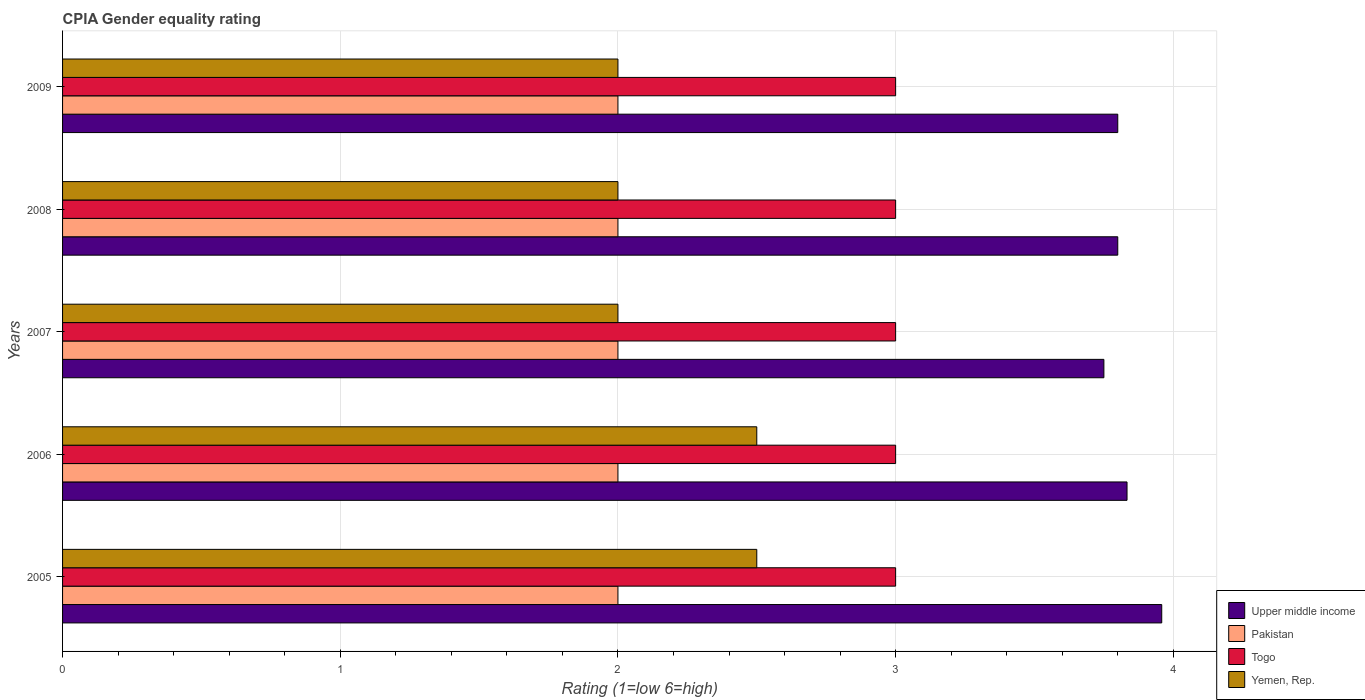Are the number of bars on each tick of the Y-axis equal?
Provide a succinct answer. Yes. How many bars are there on the 1st tick from the bottom?
Keep it short and to the point. 4. What is the CPIA rating in Togo in 2008?
Make the answer very short. 3. Across all years, what is the maximum CPIA rating in Togo?
Offer a terse response. 3. Across all years, what is the minimum CPIA rating in Upper middle income?
Offer a terse response. 3.75. In which year was the CPIA rating in Upper middle income maximum?
Offer a very short reply. 2005. What is the total CPIA rating in Togo in the graph?
Offer a terse response. 15. What is the difference between the CPIA rating in Yemen, Rep. in 2009 and the CPIA rating in Upper middle income in 2008?
Ensure brevity in your answer.  -1.8. Is the difference between the CPIA rating in Togo in 2005 and 2009 greater than the difference between the CPIA rating in Yemen, Rep. in 2005 and 2009?
Provide a short and direct response. No. What is the difference between the highest and the lowest CPIA rating in Upper middle income?
Your response must be concise. 0.21. Is the sum of the CPIA rating in Togo in 2008 and 2009 greater than the maximum CPIA rating in Upper middle income across all years?
Offer a terse response. Yes. What does the 3rd bar from the top in 2009 represents?
Ensure brevity in your answer.  Pakistan. What does the 3rd bar from the bottom in 2009 represents?
Provide a succinct answer. Togo. Is it the case that in every year, the sum of the CPIA rating in Upper middle income and CPIA rating in Yemen, Rep. is greater than the CPIA rating in Togo?
Keep it short and to the point. Yes. How many bars are there?
Offer a terse response. 20. Are all the bars in the graph horizontal?
Offer a terse response. Yes. How many years are there in the graph?
Your answer should be very brief. 5. What is the difference between two consecutive major ticks on the X-axis?
Provide a succinct answer. 1. Does the graph contain any zero values?
Your answer should be compact. No. Where does the legend appear in the graph?
Your answer should be compact. Bottom right. How many legend labels are there?
Give a very brief answer. 4. How are the legend labels stacked?
Give a very brief answer. Vertical. What is the title of the graph?
Ensure brevity in your answer.  CPIA Gender equality rating. Does "Monaco" appear as one of the legend labels in the graph?
Provide a succinct answer. No. What is the label or title of the Y-axis?
Keep it short and to the point. Years. What is the Rating (1=low 6=high) of Upper middle income in 2005?
Offer a terse response. 3.96. What is the Rating (1=low 6=high) of Togo in 2005?
Provide a succinct answer. 3. What is the Rating (1=low 6=high) in Yemen, Rep. in 2005?
Offer a terse response. 2.5. What is the Rating (1=low 6=high) in Upper middle income in 2006?
Offer a very short reply. 3.83. What is the Rating (1=low 6=high) in Yemen, Rep. in 2006?
Give a very brief answer. 2.5. What is the Rating (1=low 6=high) in Upper middle income in 2007?
Make the answer very short. 3.75. What is the Rating (1=low 6=high) of Pakistan in 2007?
Your answer should be very brief. 2. What is the Rating (1=low 6=high) of Togo in 2007?
Make the answer very short. 3. What is the Rating (1=low 6=high) of Upper middle income in 2008?
Offer a very short reply. 3.8. What is the Rating (1=low 6=high) of Pakistan in 2008?
Provide a short and direct response. 2. What is the Rating (1=low 6=high) in Yemen, Rep. in 2008?
Give a very brief answer. 2. What is the Rating (1=low 6=high) of Upper middle income in 2009?
Your answer should be compact. 3.8. What is the Rating (1=low 6=high) in Togo in 2009?
Offer a terse response. 3. What is the Rating (1=low 6=high) of Yemen, Rep. in 2009?
Ensure brevity in your answer.  2. Across all years, what is the maximum Rating (1=low 6=high) of Upper middle income?
Your answer should be very brief. 3.96. Across all years, what is the maximum Rating (1=low 6=high) in Pakistan?
Your answer should be very brief. 2. Across all years, what is the maximum Rating (1=low 6=high) of Togo?
Offer a terse response. 3. Across all years, what is the minimum Rating (1=low 6=high) in Upper middle income?
Your answer should be very brief. 3.75. Across all years, what is the minimum Rating (1=low 6=high) of Yemen, Rep.?
Your response must be concise. 2. What is the total Rating (1=low 6=high) of Upper middle income in the graph?
Your answer should be compact. 19.14. What is the total Rating (1=low 6=high) in Pakistan in the graph?
Offer a very short reply. 10. What is the total Rating (1=low 6=high) of Togo in the graph?
Make the answer very short. 15. What is the difference between the Rating (1=low 6=high) of Upper middle income in 2005 and that in 2006?
Keep it short and to the point. 0.12. What is the difference between the Rating (1=low 6=high) in Pakistan in 2005 and that in 2006?
Your answer should be very brief. 0. What is the difference between the Rating (1=low 6=high) in Togo in 2005 and that in 2006?
Ensure brevity in your answer.  0. What is the difference between the Rating (1=low 6=high) of Yemen, Rep. in 2005 and that in 2006?
Give a very brief answer. 0. What is the difference between the Rating (1=low 6=high) of Upper middle income in 2005 and that in 2007?
Ensure brevity in your answer.  0.21. What is the difference between the Rating (1=low 6=high) in Pakistan in 2005 and that in 2007?
Ensure brevity in your answer.  0. What is the difference between the Rating (1=low 6=high) in Yemen, Rep. in 2005 and that in 2007?
Your answer should be very brief. 0.5. What is the difference between the Rating (1=low 6=high) of Upper middle income in 2005 and that in 2008?
Your answer should be compact. 0.16. What is the difference between the Rating (1=low 6=high) of Yemen, Rep. in 2005 and that in 2008?
Ensure brevity in your answer.  0.5. What is the difference between the Rating (1=low 6=high) of Upper middle income in 2005 and that in 2009?
Make the answer very short. 0.16. What is the difference between the Rating (1=low 6=high) of Pakistan in 2005 and that in 2009?
Ensure brevity in your answer.  0. What is the difference between the Rating (1=low 6=high) of Togo in 2005 and that in 2009?
Provide a short and direct response. 0. What is the difference between the Rating (1=low 6=high) of Yemen, Rep. in 2005 and that in 2009?
Provide a short and direct response. 0.5. What is the difference between the Rating (1=low 6=high) in Upper middle income in 2006 and that in 2007?
Make the answer very short. 0.08. What is the difference between the Rating (1=low 6=high) in Pakistan in 2006 and that in 2007?
Ensure brevity in your answer.  0. What is the difference between the Rating (1=low 6=high) in Togo in 2006 and that in 2007?
Your answer should be compact. 0. What is the difference between the Rating (1=low 6=high) in Pakistan in 2006 and that in 2008?
Ensure brevity in your answer.  0. What is the difference between the Rating (1=low 6=high) of Togo in 2006 and that in 2008?
Ensure brevity in your answer.  0. What is the difference between the Rating (1=low 6=high) in Yemen, Rep. in 2006 and that in 2008?
Offer a very short reply. 0.5. What is the difference between the Rating (1=low 6=high) in Upper middle income in 2006 and that in 2009?
Your response must be concise. 0.03. What is the difference between the Rating (1=low 6=high) in Pakistan in 2006 and that in 2009?
Your response must be concise. 0. What is the difference between the Rating (1=low 6=high) in Togo in 2006 and that in 2009?
Make the answer very short. 0. What is the difference between the Rating (1=low 6=high) of Yemen, Rep. in 2007 and that in 2008?
Your answer should be compact. 0. What is the difference between the Rating (1=low 6=high) of Pakistan in 2007 and that in 2009?
Ensure brevity in your answer.  0. What is the difference between the Rating (1=low 6=high) in Upper middle income in 2008 and that in 2009?
Give a very brief answer. 0. What is the difference between the Rating (1=low 6=high) in Togo in 2008 and that in 2009?
Your response must be concise. 0. What is the difference between the Rating (1=low 6=high) of Yemen, Rep. in 2008 and that in 2009?
Make the answer very short. 0. What is the difference between the Rating (1=low 6=high) of Upper middle income in 2005 and the Rating (1=low 6=high) of Pakistan in 2006?
Provide a succinct answer. 1.96. What is the difference between the Rating (1=low 6=high) in Upper middle income in 2005 and the Rating (1=low 6=high) in Yemen, Rep. in 2006?
Your response must be concise. 1.46. What is the difference between the Rating (1=low 6=high) in Pakistan in 2005 and the Rating (1=low 6=high) in Togo in 2006?
Your answer should be compact. -1. What is the difference between the Rating (1=low 6=high) in Pakistan in 2005 and the Rating (1=low 6=high) in Yemen, Rep. in 2006?
Give a very brief answer. -0.5. What is the difference between the Rating (1=low 6=high) of Togo in 2005 and the Rating (1=low 6=high) of Yemen, Rep. in 2006?
Offer a very short reply. 0.5. What is the difference between the Rating (1=low 6=high) in Upper middle income in 2005 and the Rating (1=low 6=high) in Pakistan in 2007?
Your answer should be compact. 1.96. What is the difference between the Rating (1=low 6=high) of Upper middle income in 2005 and the Rating (1=low 6=high) of Togo in 2007?
Make the answer very short. 0.96. What is the difference between the Rating (1=low 6=high) in Upper middle income in 2005 and the Rating (1=low 6=high) in Yemen, Rep. in 2007?
Make the answer very short. 1.96. What is the difference between the Rating (1=low 6=high) of Pakistan in 2005 and the Rating (1=low 6=high) of Yemen, Rep. in 2007?
Make the answer very short. 0. What is the difference between the Rating (1=low 6=high) in Upper middle income in 2005 and the Rating (1=low 6=high) in Pakistan in 2008?
Provide a short and direct response. 1.96. What is the difference between the Rating (1=low 6=high) in Upper middle income in 2005 and the Rating (1=low 6=high) in Yemen, Rep. in 2008?
Ensure brevity in your answer.  1.96. What is the difference between the Rating (1=low 6=high) in Pakistan in 2005 and the Rating (1=low 6=high) in Yemen, Rep. in 2008?
Offer a terse response. 0. What is the difference between the Rating (1=low 6=high) in Upper middle income in 2005 and the Rating (1=low 6=high) in Pakistan in 2009?
Give a very brief answer. 1.96. What is the difference between the Rating (1=low 6=high) of Upper middle income in 2005 and the Rating (1=low 6=high) of Yemen, Rep. in 2009?
Offer a very short reply. 1.96. What is the difference between the Rating (1=low 6=high) in Pakistan in 2005 and the Rating (1=low 6=high) in Togo in 2009?
Give a very brief answer. -1. What is the difference between the Rating (1=low 6=high) in Togo in 2005 and the Rating (1=low 6=high) in Yemen, Rep. in 2009?
Give a very brief answer. 1. What is the difference between the Rating (1=low 6=high) of Upper middle income in 2006 and the Rating (1=low 6=high) of Pakistan in 2007?
Your response must be concise. 1.83. What is the difference between the Rating (1=low 6=high) of Upper middle income in 2006 and the Rating (1=low 6=high) of Yemen, Rep. in 2007?
Ensure brevity in your answer.  1.83. What is the difference between the Rating (1=low 6=high) in Upper middle income in 2006 and the Rating (1=low 6=high) in Pakistan in 2008?
Ensure brevity in your answer.  1.83. What is the difference between the Rating (1=low 6=high) in Upper middle income in 2006 and the Rating (1=low 6=high) in Yemen, Rep. in 2008?
Make the answer very short. 1.83. What is the difference between the Rating (1=low 6=high) in Pakistan in 2006 and the Rating (1=low 6=high) in Togo in 2008?
Offer a very short reply. -1. What is the difference between the Rating (1=low 6=high) in Upper middle income in 2006 and the Rating (1=low 6=high) in Pakistan in 2009?
Give a very brief answer. 1.83. What is the difference between the Rating (1=low 6=high) in Upper middle income in 2006 and the Rating (1=low 6=high) in Togo in 2009?
Keep it short and to the point. 0.83. What is the difference between the Rating (1=low 6=high) of Upper middle income in 2006 and the Rating (1=low 6=high) of Yemen, Rep. in 2009?
Offer a terse response. 1.83. What is the difference between the Rating (1=low 6=high) in Pakistan in 2006 and the Rating (1=low 6=high) in Yemen, Rep. in 2009?
Make the answer very short. 0. What is the difference between the Rating (1=low 6=high) in Togo in 2006 and the Rating (1=low 6=high) in Yemen, Rep. in 2009?
Give a very brief answer. 1. What is the difference between the Rating (1=low 6=high) of Upper middle income in 2007 and the Rating (1=low 6=high) of Togo in 2008?
Offer a very short reply. 0.75. What is the difference between the Rating (1=low 6=high) of Pakistan in 2007 and the Rating (1=low 6=high) of Togo in 2008?
Provide a succinct answer. -1. What is the difference between the Rating (1=low 6=high) of Pakistan in 2007 and the Rating (1=low 6=high) of Yemen, Rep. in 2008?
Offer a terse response. 0. What is the difference between the Rating (1=low 6=high) of Togo in 2007 and the Rating (1=low 6=high) of Yemen, Rep. in 2008?
Offer a terse response. 1. What is the difference between the Rating (1=low 6=high) of Upper middle income in 2007 and the Rating (1=low 6=high) of Togo in 2009?
Offer a terse response. 0.75. What is the difference between the Rating (1=low 6=high) in Upper middle income in 2007 and the Rating (1=low 6=high) in Yemen, Rep. in 2009?
Your answer should be very brief. 1.75. What is the difference between the Rating (1=low 6=high) of Pakistan in 2007 and the Rating (1=low 6=high) of Togo in 2009?
Ensure brevity in your answer.  -1. What is the difference between the Rating (1=low 6=high) of Upper middle income in 2008 and the Rating (1=low 6=high) of Pakistan in 2009?
Give a very brief answer. 1.8. What is the difference between the Rating (1=low 6=high) in Upper middle income in 2008 and the Rating (1=low 6=high) in Togo in 2009?
Offer a very short reply. 0.8. What is the difference between the Rating (1=low 6=high) of Pakistan in 2008 and the Rating (1=low 6=high) of Togo in 2009?
Give a very brief answer. -1. What is the average Rating (1=low 6=high) in Upper middle income per year?
Make the answer very short. 3.83. What is the average Rating (1=low 6=high) in Pakistan per year?
Keep it short and to the point. 2. What is the average Rating (1=low 6=high) in Yemen, Rep. per year?
Your answer should be very brief. 2.2. In the year 2005, what is the difference between the Rating (1=low 6=high) of Upper middle income and Rating (1=low 6=high) of Pakistan?
Offer a very short reply. 1.96. In the year 2005, what is the difference between the Rating (1=low 6=high) of Upper middle income and Rating (1=low 6=high) of Togo?
Make the answer very short. 0.96. In the year 2005, what is the difference between the Rating (1=low 6=high) in Upper middle income and Rating (1=low 6=high) in Yemen, Rep.?
Give a very brief answer. 1.46. In the year 2005, what is the difference between the Rating (1=low 6=high) in Pakistan and Rating (1=low 6=high) in Togo?
Your response must be concise. -1. In the year 2005, what is the difference between the Rating (1=low 6=high) in Pakistan and Rating (1=low 6=high) in Yemen, Rep.?
Provide a short and direct response. -0.5. In the year 2005, what is the difference between the Rating (1=low 6=high) of Togo and Rating (1=low 6=high) of Yemen, Rep.?
Keep it short and to the point. 0.5. In the year 2006, what is the difference between the Rating (1=low 6=high) in Upper middle income and Rating (1=low 6=high) in Pakistan?
Keep it short and to the point. 1.83. In the year 2006, what is the difference between the Rating (1=low 6=high) in Upper middle income and Rating (1=low 6=high) in Togo?
Give a very brief answer. 0.83. In the year 2006, what is the difference between the Rating (1=low 6=high) of Pakistan and Rating (1=low 6=high) of Togo?
Give a very brief answer. -1. In the year 2006, what is the difference between the Rating (1=low 6=high) in Pakistan and Rating (1=low 6=high) in Yemen, Rep.?
Offer a terse response. -0.5. In the year 2006, what is the difference between the Rating (1=low 6=high) in Togo and Rating (1=low 6=high) in Yemen, Rep.?
Offer a very short reply. 0.5. In the year 2007, what is the difference between the Rating (1=low 6=high) in Upper middle income and Rating (1=low 6=high) in Pakistan?
Offer a terse response. 1.75. In the year 2007, what is the difference between the Rating (1=low 6=high) of Upper middle income and Rating (1=low 6=high) of Yemen, Rep.?
Offer a very short reply. 1.75. In the year 2007, what is the difference between the Rating (1=low 6=high) of Togo and Rating (1=low 6=high) of Yemen, Rep.?
Offer a very short reply. 1. In the year 2008, what is the difference between the Rating (1=low 6=high) of Upper middle income and Rating (1=low 6=high) of Pakistan?
Your response must be concise. 1.8. In the year 2008, what is the difference between the Rating (1=low 6=high) in Upper middle income and Rating (1=low 6=high) in Togo?
Your answer should be very brief. 0.8. In the year 2008, what is the difference between the Rating (1=low 6=high) in Upper middle income and Rating (1=low 6=high) in Yemen, Rep.?
Ensure brevity in your answer.  1.8. In the year 2008, what is the difference between the Rating (1=low 6=high) in Pakistan and Rating (1=low 6=high) in Togo?
Give a very brief answer. -1. In the year 2008, what is the difference between the Rating (1=low 6=high) in Togo and Rating (1=low 6=high) in Yemen, Rep.?
Provide a short and direct response. 1. In the year 2009, what is the difference between the Rating (1=low 6=high) in Upper middle income and Rating (1=low 6=high) in Togo?
Your response must be concise. 0.8. In the year 2009, what is the difference between the Rating (1=low 6=high) in Upper middle income and Rating (1=low 6=high) in Yemen, Rep.?
Provide a succinct answer. 1.8. In the year 2009, what is the difference between the Rating (1=low 6=high) in Pakistan and Rating (1=low 6=high) in Yemen, Rep.?
Offer a very short reply. 0. In the year 2009, what is the difference between the Rating (1=low 6=high) of Togo and Rating (1=low 6=high) of Yemen, Rep.?
Your response must be concise. 1. What is the ratio of the Rating (1=low 6=high) of Upper middle income in 2005 to that in 2006?
Your answer should be compact. 1.03. What is the ratio of the Rating (1=low 6=high) in Pakistan in 2005 to that in 2006?
Your answer should be compact. 1. What is the ratio of the Rating (1=low 6=high) in Upper middle income in 2005 to that in 2007?
Your answer should be very brief. 1.06. What is the ratio of the Rating (1=low 6=high) in Pakistan in 2005 to that in 2007?
Make the answer very short. 1. What is the ratio of the Rating (1=low 6=high) of Upper middle income in 2005 to that in 2008?
Ensure brevity in your answer.  1.04. What is the ratio of the Rating (1=low 6=high) in Pakistan in 2005 to that in 2008?
Your answer should be compact. 1. What is the ratio of the Rating (1=low 6=high) in Yemen, Rep. in 2005 to that in 2008?
Make the answer very short. 1.25. What is the ratio of the Rating (1=low 6=high) in Upper middle income in 2005 to that in 2009?
Keep it short and to the point. 1.04. What is the ratio of the Rating (1=low 6=high) in Togo in 2005 to that in 2009?
Your answer should be compact. 1. What is the ratio of the Rating (1=low 6=high) of Yemen, Rep. in 2005 to that in 2009?
Keep it short and to the point. 1.25. What is the ratio of the Rating (1=low 6=high) in Upper middle income in 2006 to that in 2007?
Offer a very short reply. 1.02. What is the ratio of the Rating (1=low 6=high) of Togo in 2006 to that in 2007?
Your answer should be very brief. 1. What is the ratio of the Rating (1=low 6=high) in Upper middle income in 2006 to that in 2008?
Your answer should be compact. 1.01. What is the ratio of the Rating (1=low 6=high) in Yemen, Rep. in 2006 to that in 2008?
Offer a terse response. 1.25. What is the ratio of the Rating (1=low 6=high) in Upper middle income in 2006 to that in 2009?
Give a very brief answer. 1.01. What is the ratio of the Rating (1=low 6=high) in Togo in 2006 to that in 2009?
Provide a short and direct response. 1. What is the ratio of the Rating (1=low 6=high) of Yemen, Rep. in 2006 to that in 2009?
Your response must be concise. 1.25. What is the ratio of the Rating (1=low 6=high) in Upper middle income in 2007 to that in 2008?
Ensure brevity in your answer.  0.99. What is the ratio of the Rating (1=low 6=high) in Togo in 2007 to that in 2008?
Offer a terse response. 1. What is the ratio of the Rating (1=low 6=high) in Yemen, Rep. in 2007 to that in 2009?
Provide a short and direct response. 1. What is the ratio of the Rating (1=low 6=high) in Upper middle income in 2008 to that in 2009?
Offer a terse response. 1. What is the ratio of the Rating (1=low 6=high) in Togo in 2008 to that in 2009?
Keep it short and to the point. 1. What is the ratio of the Rating (1=low 6=high) of Yemen, Rep. in 2008 to that in 2009?
Offer a very short reply. 1. What is the difference between the highest and the second highest Rating (1=low 6=high) of Upper middle income?
Your answer should be compact. 0.12. What is the difference between the highest and the second highest Rating (1=low 6=high) in Togo?
Provide a succinct answer. 0. What is the difference between the highest and the lowest Rating (1=low 6=high) in Upper middle income?
Offer a very short reply. 0.21. What is the difference between the highest and the lowest Rating (1=low 6=high) in Pakistan?
Your answer should be very brief. 0. 